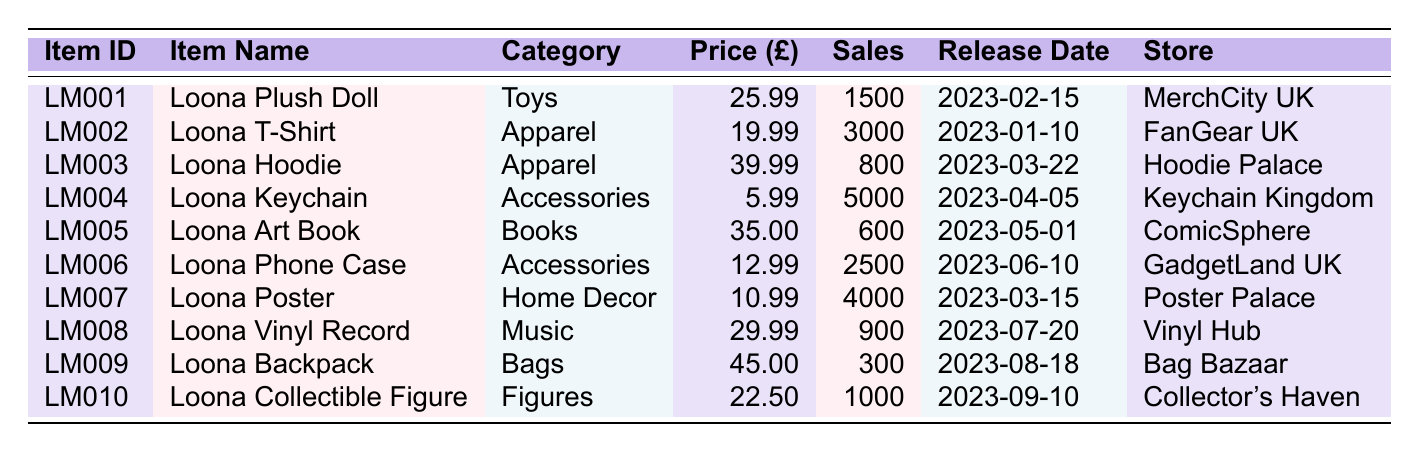What is the highest sales volume among the items? The highest sales volume is found in the Loona Keychain, which has a sales volume of 5000.
Answer: 5000 Which item has the lowest price? By examining the price column, the Loona Keychain has the lowest price at £5.99.
Answer: £5.99 How much did the Loona T-Shirt make in total sales revenue? To find the total sales revenue, multiply the price of the T-Shirt (£19.99) by its sales volume (3000). Total = 19.99 * 3000 = £59,970.
Answer: £59,970 Is the sales volume of the Loona Plush Doll greater than that of the Loona Vinyl Record? The sales volume of the Loona Plush Doll is 1500, while the Loona Vinyl Record has a sales volume of 900. Therefore, the Plush Doll's sales volume is indeed greater.
Answer: Yes What is the average price of all the items in the table? First, add up all the prices: (25.99 + 19.99 + 39.99 + 5.99 + 35.00 + 12.99 + 10.99 + 29.99 + 45.00 + 22.50) = £  231.43. Then, divide by the number of items (10): 231.43 / 10 = £23.14.
Answer: £23.14 Compare the sales volume of items released after April 2023. Which item had the highest sales volume? After filtering, the items released post-April are the Loona Phone Case (2500), Loona Poster (4000), Loona Vinyl Record (900), Loona Backpack (300), and Loona Collectible Figure (1000). The Loona Poster has the highest sales volume of 4000.
Answer: 4000 What is the total sales revenue generated from the Loona Collectible Figure? The total sales revenue is calculated by multiplying its price (£22.50) by its sales volume (1000). Total = 22.50 * 1000 = £22,500.
Answer: £22,500 Is the total sales volume for all accessories greater than for all apparel items? The sales volume for accessories includes the Loona Keychain (5000) and Loona Phone Case (2500), totaling 7500. The apparel items include the Loona T-Shirt (3000) and Loona Hoodie (800), totaling 3800. Since 7500 is greater than 3800, the statement is true.
Answer: Yes What percentage of total sales volume does the Loona Poster contribute? The total sales volume across all products is 1500 + 3000 + 800 + 5000 + 600 + 2500 + 4000 + 900 + 300 + 1000 = 11900. The Loona Poster has a sales volume of 4000. To find the percentage: (4000 / 11900) * 100 ≈ 33.61%.
Answer: 33.61% 